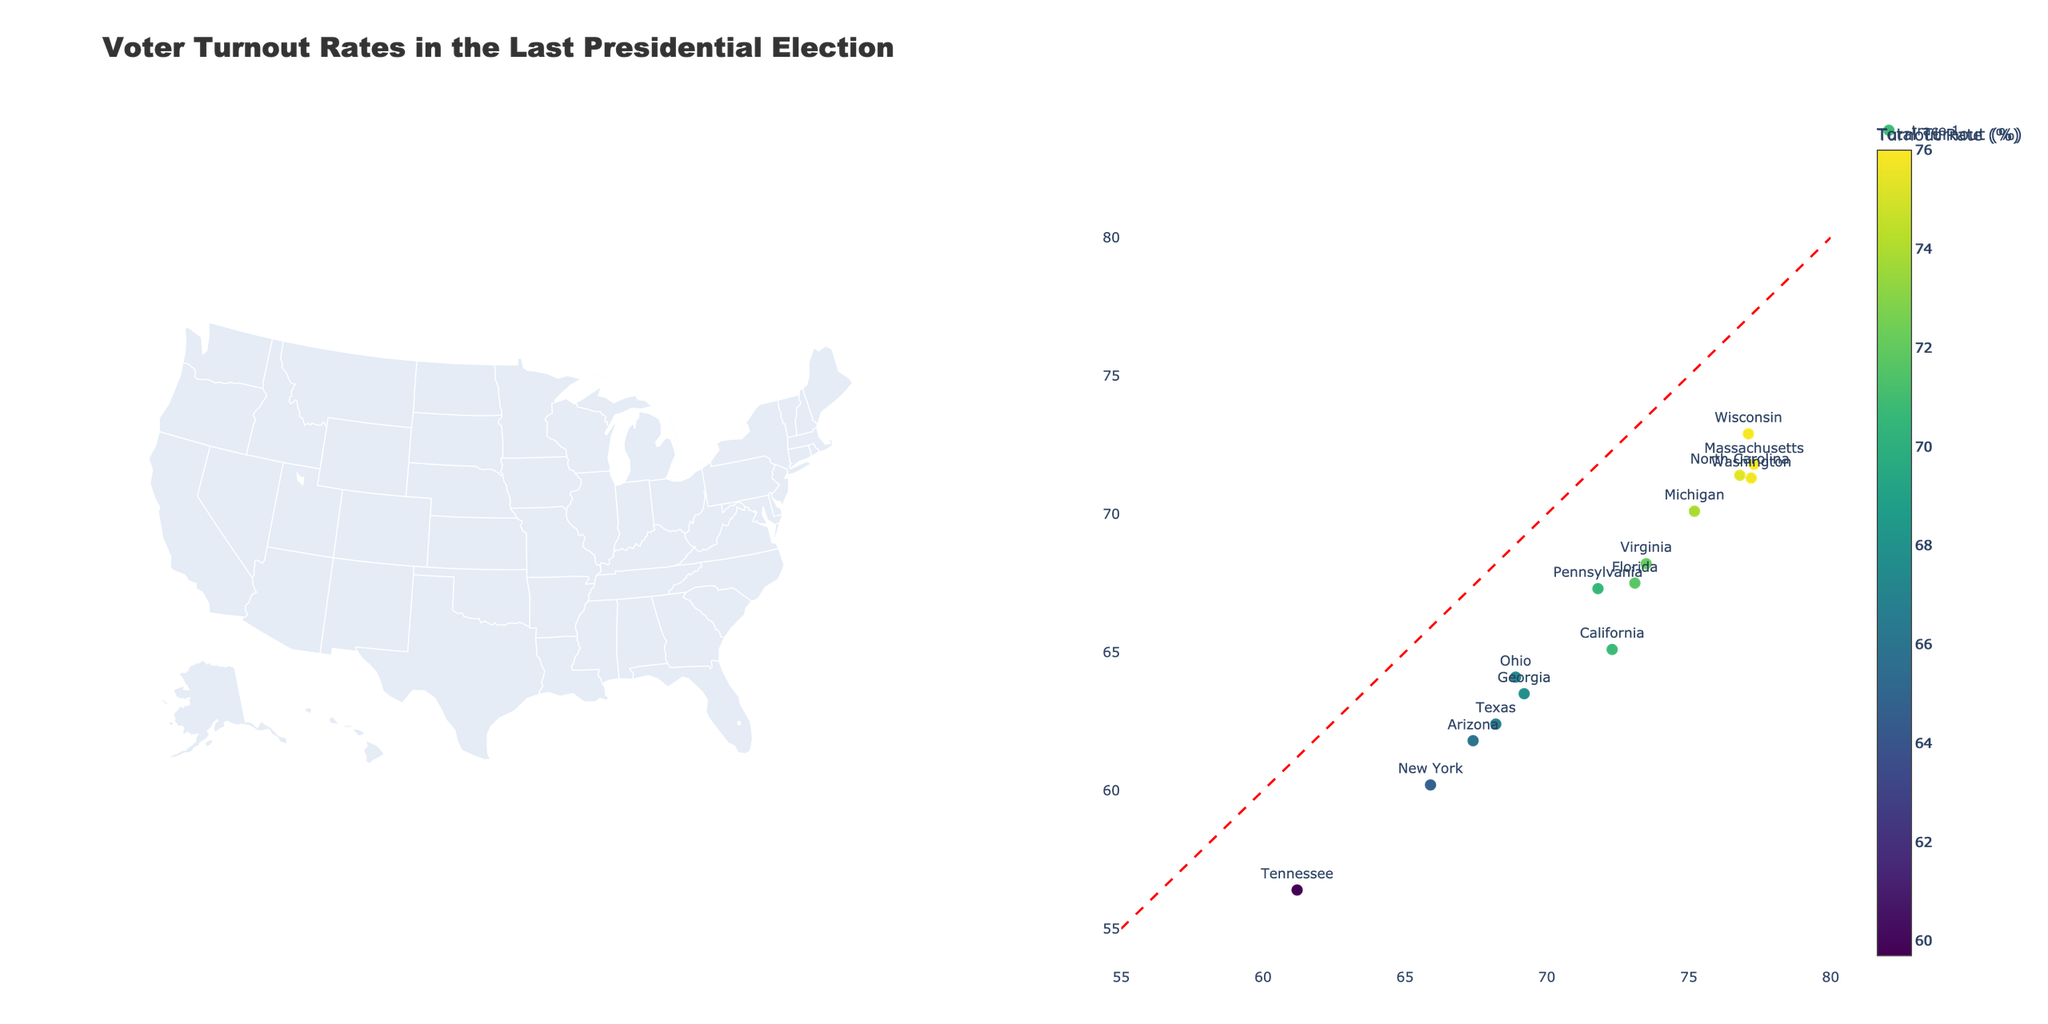what is the state with the highest total voter turnout rate? Look at the color scale to determine the state with the deepest color indicating the highest voter turnout. From the figure, Massachusetts has the highest total voter turnout rate at 76.0%.
Answer: Massachusetts Which state has the lowest rural turnout rate? From the data in the figure, find the state with the lowest voter turnout in rural areas. Tennessee has the lowest rural turnout at 56.4%.
Answer: Tennessee Is urban voter turnout generally higher than rural voter turnout? Compare the urban and rural turnout rates for each state by observing their hover texts or the scatter plot. In most states, urban turnout is higher than rural turnout.
Answer: Yes What’s the difference in urban turnout between California and Texas? Identify the urban turnout rates for California (72.3%) and Texas (68.2%), then calculate the difference: 72.3 - 68.2 = 4.1%.
Answer: 4.1% Which state shows the closest rural and urban turnout rates? Examine the scatter plot for states along the diagonal line where urban and rural turnout are nearly equal. Typically, North Carolina is near the line with urban (76.8%) and rural (71.4%) turnouts. Indiana is another close contender.
Answer: North Carolina How does New York's total voter turnout compare to Florida's? Compare the color intensity or hover information text of New York (64.7%) to Florida (71.7%). Florida has a higher overall turnout compared to New York.
Answer: Florida Which state has the highest rural turnout, and what is that percentage? Point out the deepest color state for rural turnout on the hover text. Wisconsin has the highest rural turnout rate at 72.9%.
Answer: Wisconsin, 72.9% Are there any states where rural turnout exceeds urban turnout? Investigate each state's urban vs. rural comparison and find states where the rural value surpasses urban value. None of the states in the visual depict a rural turnout exceeding urban turnout.
Answer: No Which states have both urban and rural turnout rates above 70%? Identify the states where both urban and rural hover information show rates higher than 70%. Examples include Massachusetts and Washington.
Answer: Massachusetts, Washington What percentage is the urban turnout rate for Pennsylvania? On reviewing Pennsylvania’s data point or hover text, the urban turnout rate is found to be 71.8%.
Answer: 71.8% 